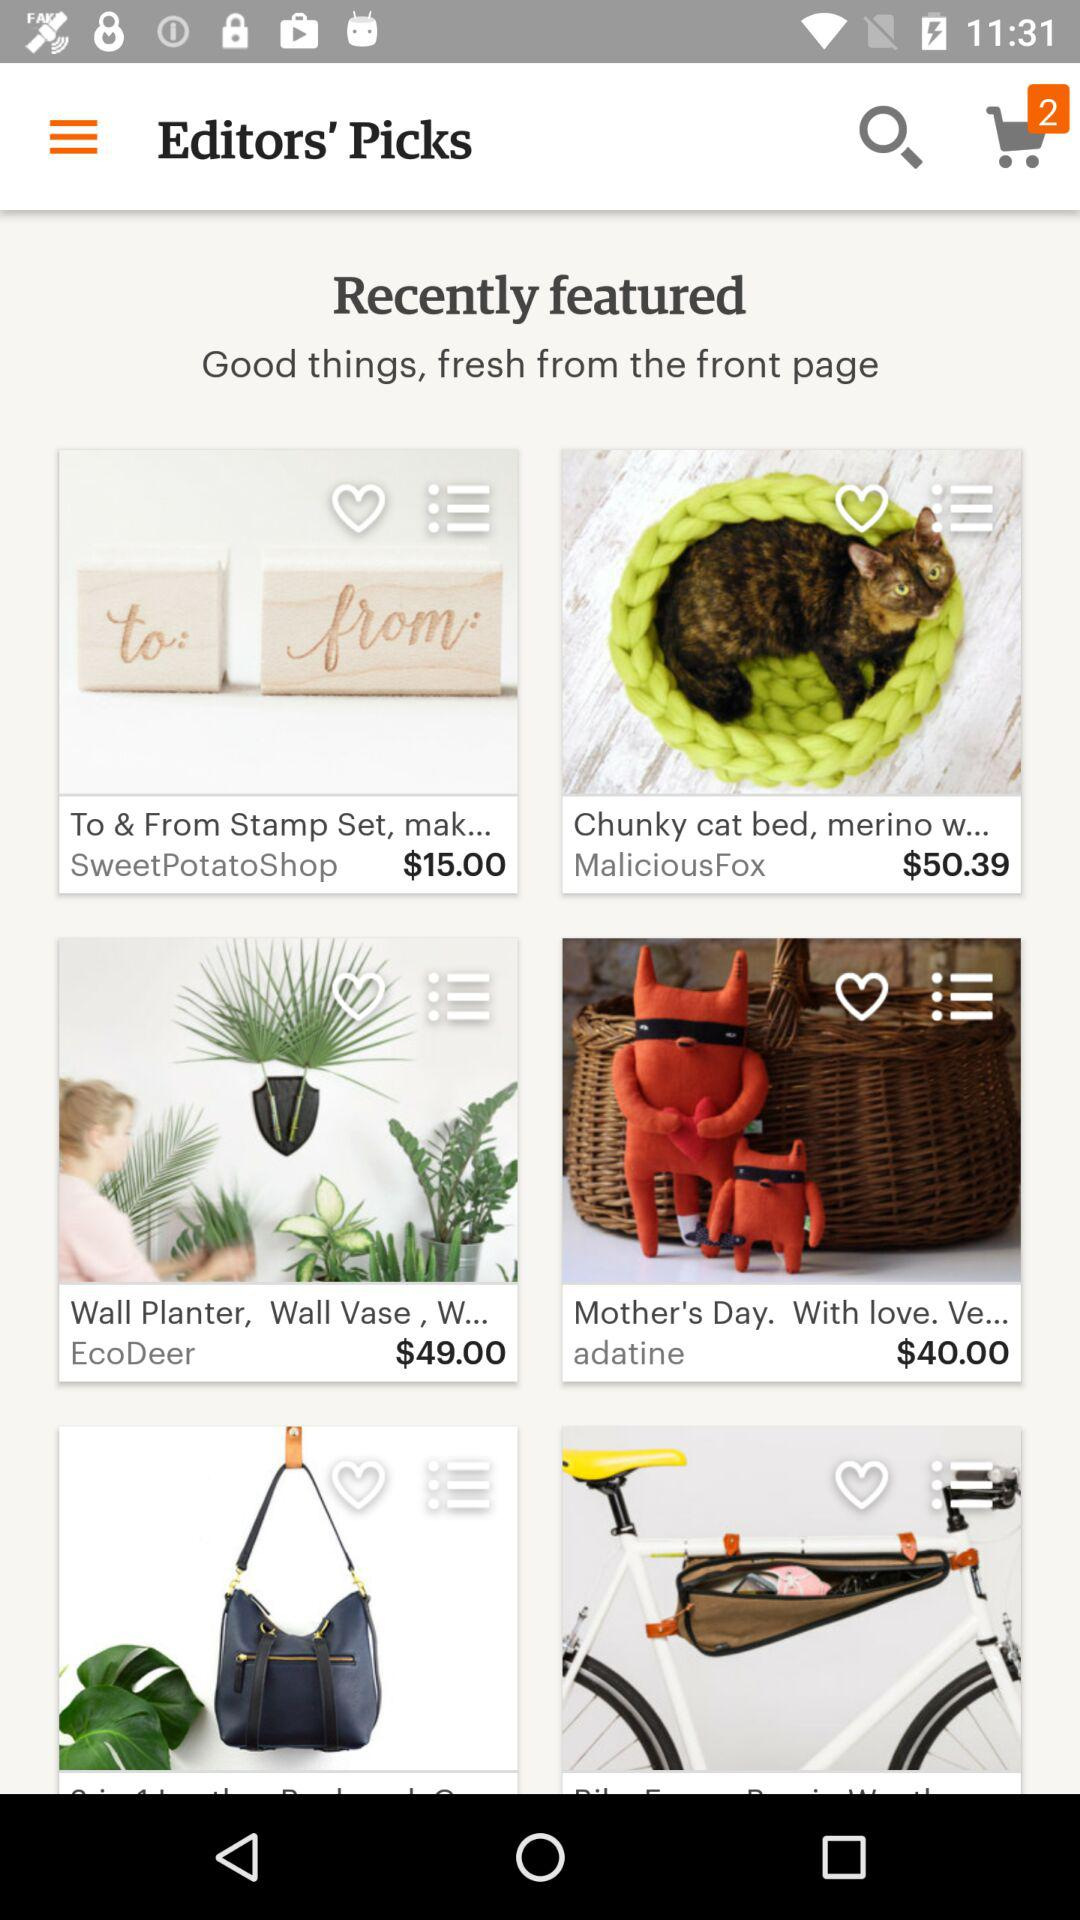How many items are in the cart? There are 2 items in the cart. 